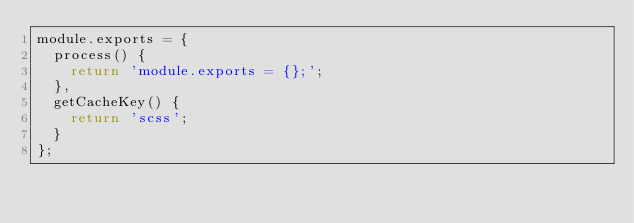<code> <loc_0><loc_0><loc_500><loc_500><_JavaScript_>module.exports = {
  process() {
    return 'module.exports = {};';
  },
  getCacheKey() {
    return 'scss';
  }
};
</code> 